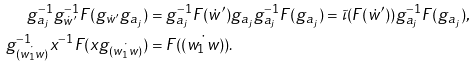<formula> <loc_0><loc_0><loc_500><loc_500>g _ { a _ { j } } ^ { - 1 } g _ { \dot { w } ^ { \prime } } ^ { - 1 } F ( g _ { \dot { w } ^ { \prime } } g _ { a _ { j } } ) & = g _ { a _ { j } } ^ { - 1 } F ( \dot { w } ^ { \prime } ) g _ { a _ { j } } g _ { a _ { j } } ^ { - 1 } F ( g _ { a _ { j } } ) = \tilde { \iota } ( F ( \dot { w } ^ { \prime } ) ) g _ { a _ { j } } ^ { - 1 } F ( g _ { a _ { j } } ) , \\ g _ { \dot { ( w _ { 1 } w ) } } ^ { - 1 } x ^ { - 1 } F ( x g _ { \dot { ( w _ { 1 } w ) } } ) & = F ( \dot { ( w _ { 1 } w ) } ) .</formula> 